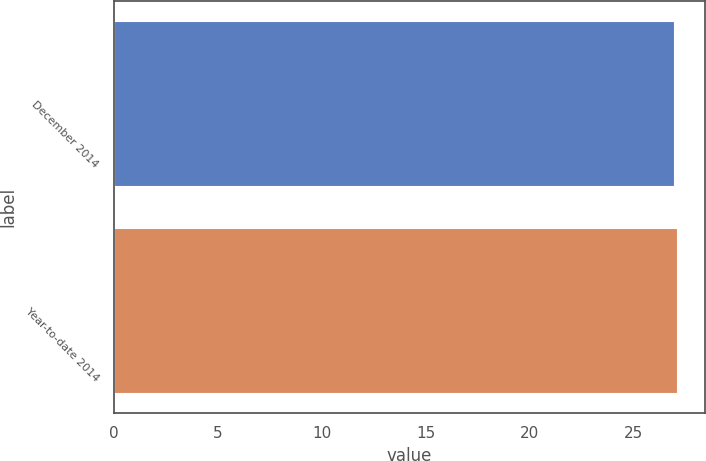Convert chart. <chart><loc_0><loc_0><loc_500><loc_500><bar_chart><fcel>December 2014<fcel>Year-to-date 2014<nl><fcel>26.95<fcel>27.05<nl></chart> 